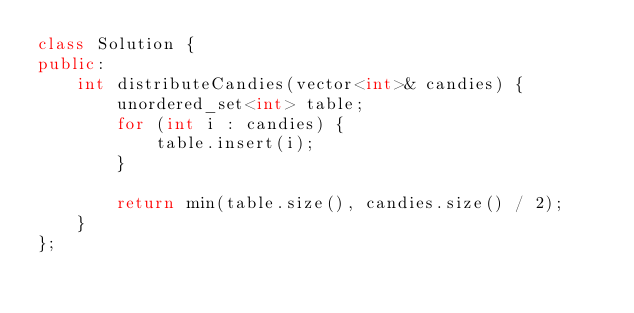Convert code to text. <code><loc_0><loc_0><loc_500><loc_500><_C++_>class Solution {
public:
    int distributeCandies(vector<int>& candies) {
        unordered_set<int> table;
        for (int i : candies) {
            table.insert(i);
        }
        
        return min(table.size(), candies.size() / 2);
    }
};
</code> 